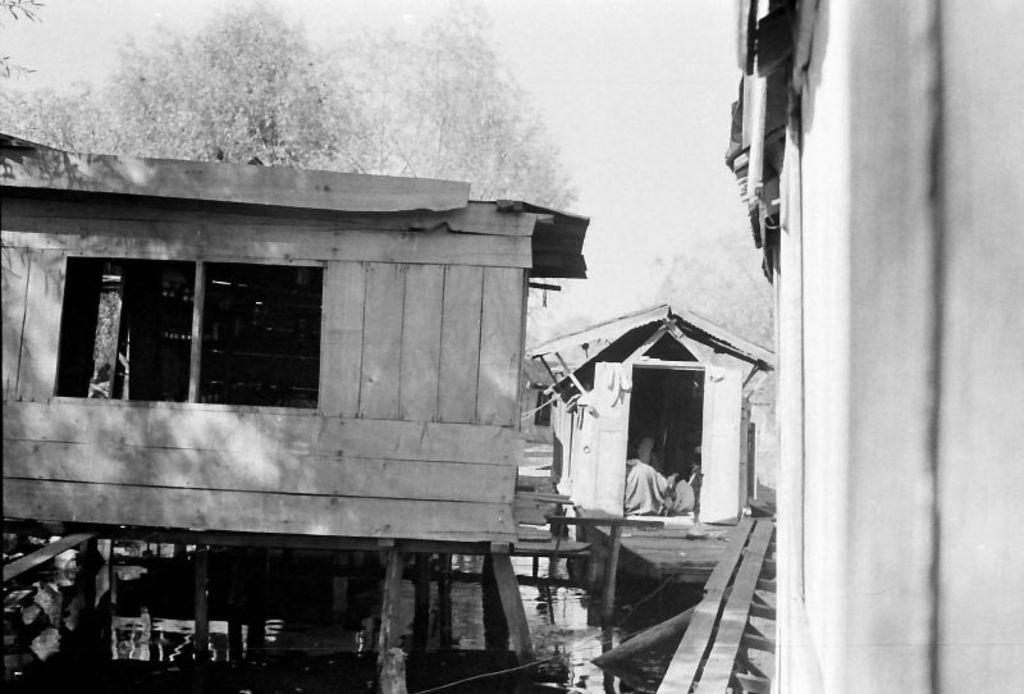What type of houses are in the image? There are wooden houses in the image. What other natural elements can be seen in the image? There are trees in the image. How would you describe the sky in the image? The sky is cloudy in the image. What type of produce is being harvested by the army in the image? There is no army or produce present in the image; it features wooden houses, trees, and a cloudy sky. 